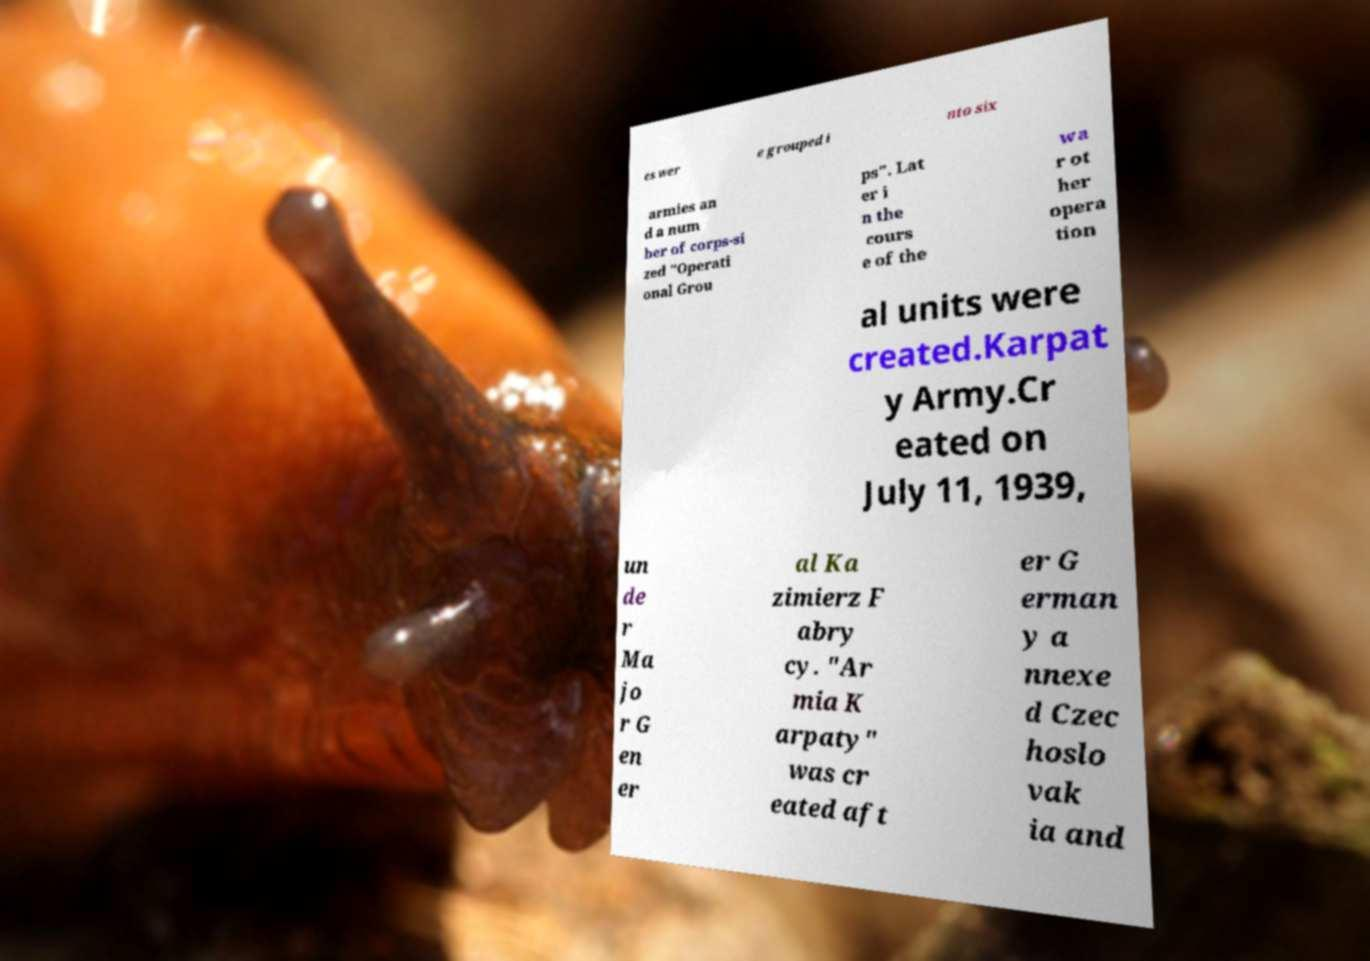Can you accurately transcribe the text from the provided image for me? es wer e grouped i nto six armies an d a num ber of corps-si zed "Operati onal Grou ps". Lat er i n the cours e of the wa r ot her opera tion al units were created.Karpat y Army.Cr eated on July 11, 1939, un de r Ma jo r G en er al Ka zimierz F abry cy. "Ar mia K arpaty" was cr eated aft er G erman y a nnexe d Czec hoslo vak ia and 